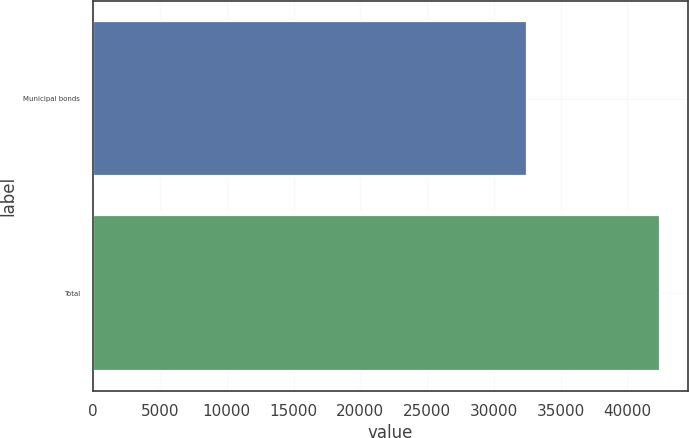<chart> <loc_0><loc_0><loc_500><loc_500><bar_chart><fcel>Municipal bonds<fcel>Total<nl><fcel>32506<fcel>42406<nl></chart> 